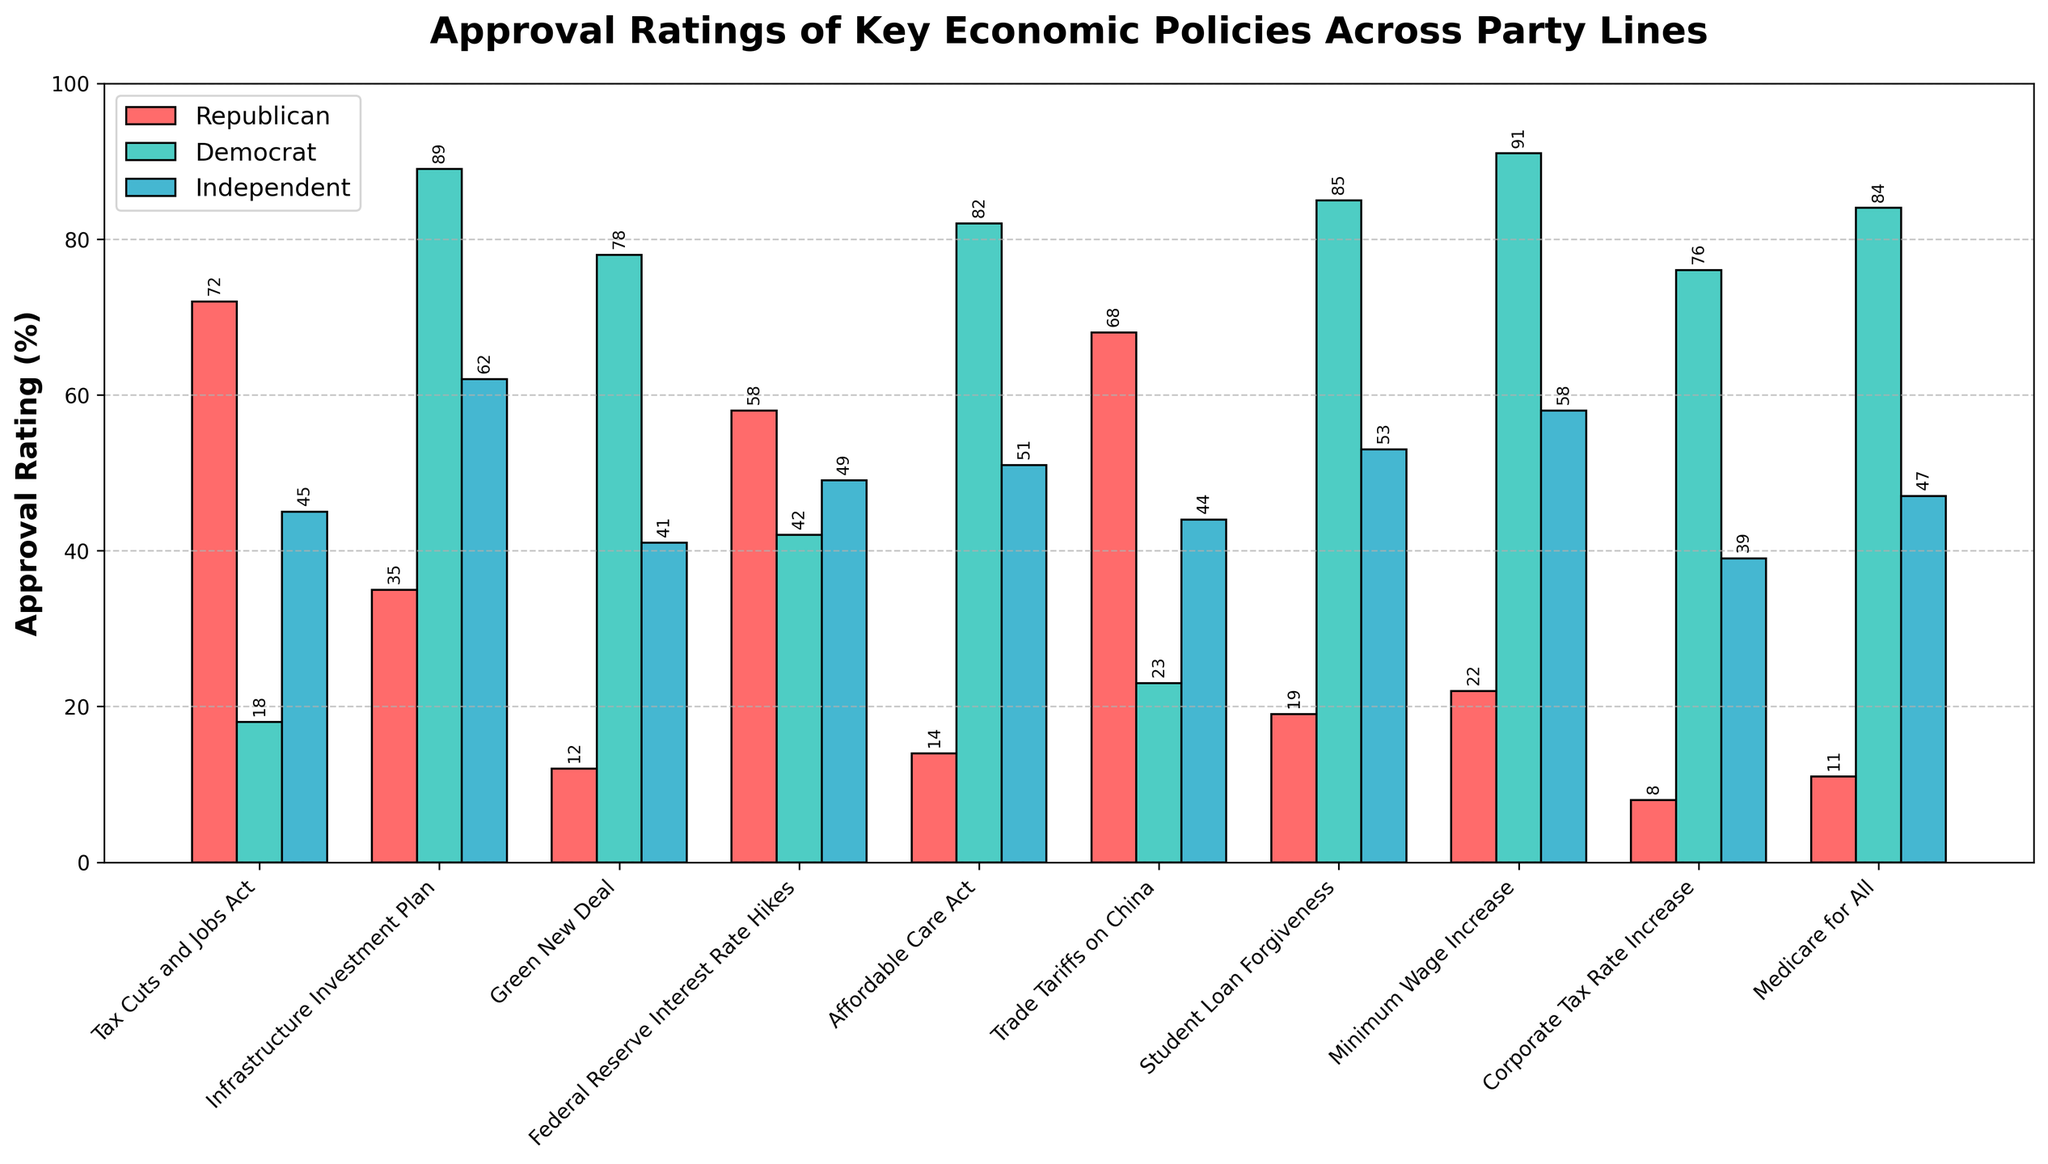What's the difference in approval ratings for the Green New Deal between Democrats and Republicans? The approval rating for the Green New Deal is 78% for Democrats and 12% for Republicans. Subtracting the Republican approval from the Democrat approval gives us 78 - 12 = 66.
Answer: 66 Which policy has the highest approval rating among Independents? By looking at the heights of the blue bars, the Minimum Wage Increase policy has the highest approval rating among Independents at 58%.
Answer: Minimum Wage Increase What’s the average approval rating of the Affordable Care Act across all parties? The approval rating for the Affordable Care Act is 14% for Republicans, 82% for Democrats, and 51% for Independents. Summing these and dividing by 3 gives (14 + 82 + 51) / 3 = 49.
Answer: 49 Which policy has the smallest difference in approval ratings between Independents and Democrats? Calculate the difference in approval ratings for each policy and find the smallest one. The smallest difference is for the Federal Reserve Interest Rate Hikes: 49% (Independent) - 42% (Democrat) = 7.
Answer: Federal Reserve Interest Rate Hikes How many policies have higher approval ratings among Republicans than Democrats? By comparing the heights of the red and green bars for each policy, note that Tax Cuts and Jobs Act, Federal Reserve Interest Rate Hikes, and Trade Tariffs on China have higher approval ratings among Republicans than Democrats. Thus, there are 3 policies.
Answer: 3 Which policy has the largest disparity in approval ratings between any two parties? Calculate the differences in approval ratings between all party pairs for each policy. The largest disparity is for the Tax Cuts and Jobs Act, where the difference between Republicans (72%) and Democrats (18%) is 72 - 18 = 54.
Answer: Tax Cuts and Jobs Act Which policies have an approval rating above 50% in at least one party? Policies with an approval rating above 50% in at least one party include: Tax Cuts and Jobs Act, Infrastructure Investment Plan, Green New Deal, Affordable Care Act, Student Loan Forgiveness, Minimum Wage Increase, Corporate Tax Rate Increase, and Medicare for All.
Answer: 8 policies What is the range of approval ratings among Republicans? The highest approval rating among Republicans is 72% for the Tax Cuts and Jobs Act, and the lowest is 8% for the Corporate Tax Rate Increase. The range is thus 72 - 8 = 64.
Answer: 64 Which policy has the closest approval ratings between Republicans and Independents? Calculate the differences in approval ratings for each policy between Republicans and Independents. The closest is for Trade Tariffs on China with a difference of 68% (Republican) - 44% (Independent) = 24.
Answer: Trade Tariffs on China 